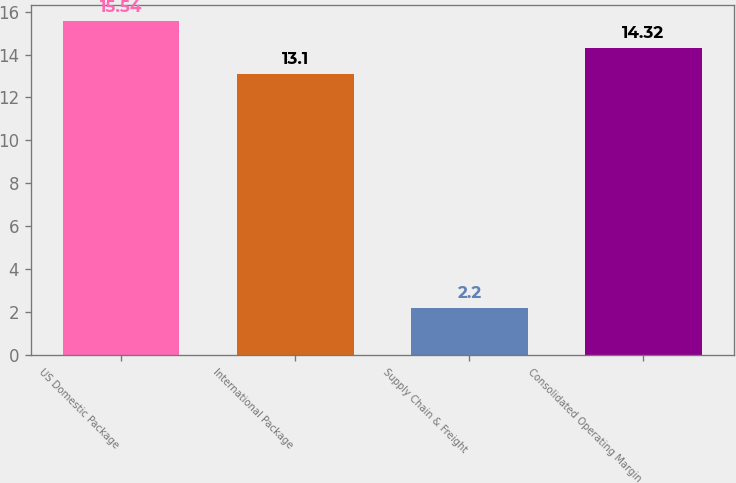<chart> <loc_0><loc_0><loc_500><loc_500><bar_chart><fcel>US Domestic Package<fcel>International Package<fcel>Supply Chain & Freight<fcel>Consolidated Operating Margin<nl><fcel>15.54<fcel>13.1<fcel>2.2<fcel>14.32<nl></chart> 